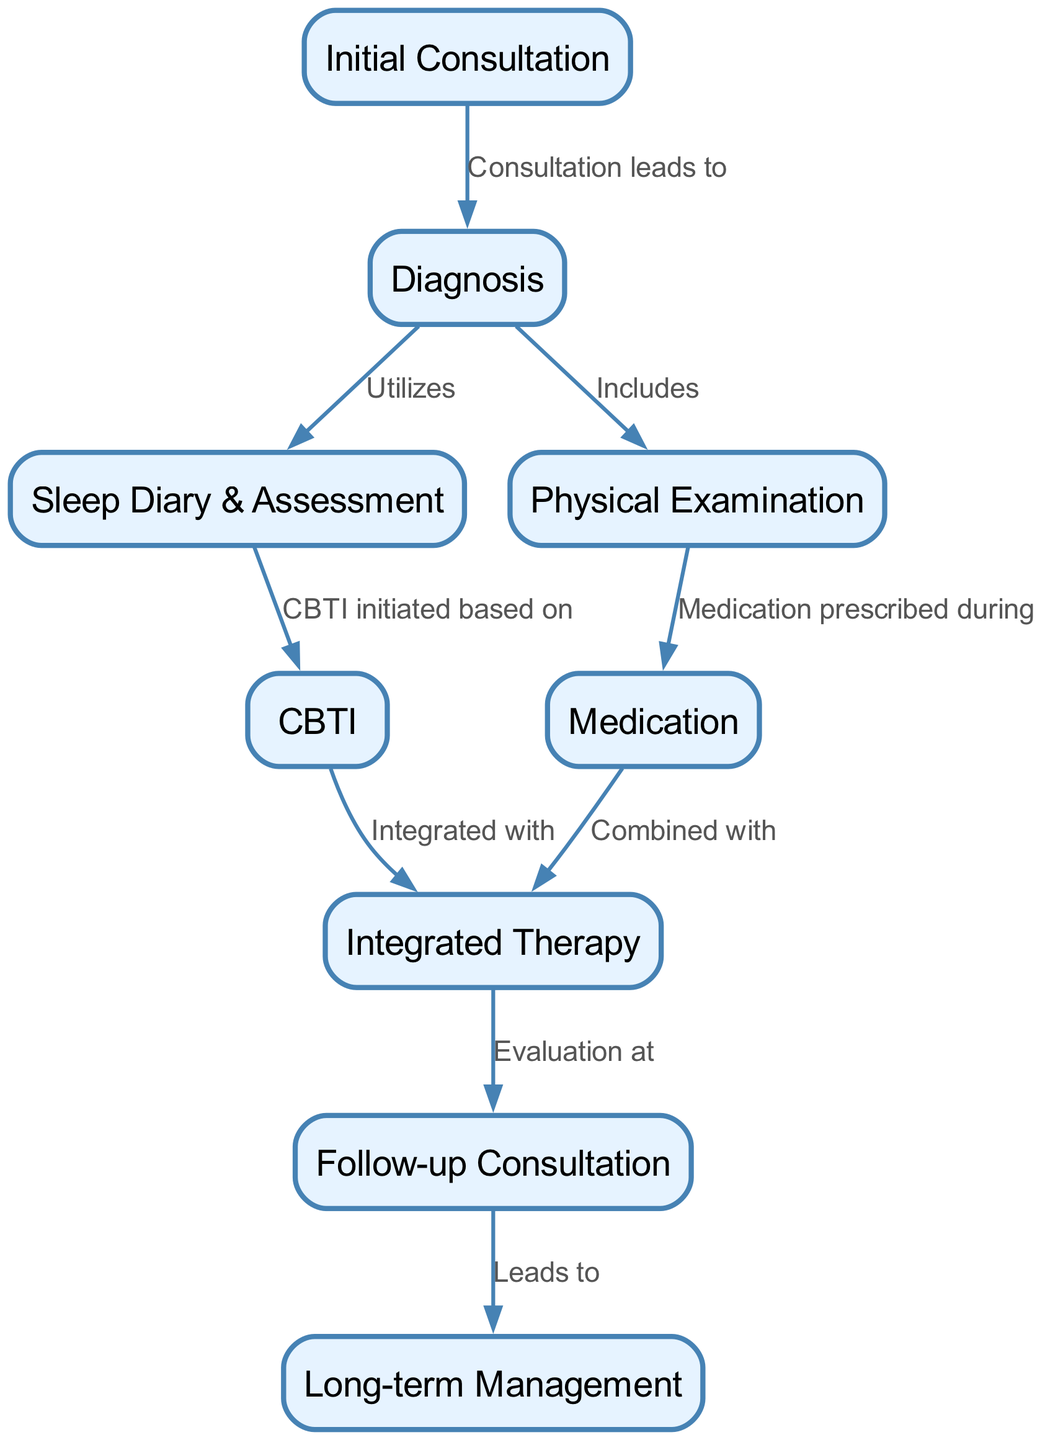What is the first step in the treatment journey? The first step in the treatment journey is indicated by the starting node labeled "Initial Consultation". This is the first action that initiates the patient journey towards addressing insomnia.
Answer: Initial Consultation How many total nodes are present in the diagram? To count the total nodes, we can look at the node data provided. There are 9 different nodes listed in the nodes section of the data, which represent the various steps in the treatment journey.
Answer: 9 What does "Diagnosis" lead to? The "Diagnosis" node is connected to two subsequent nodes: "Sleep Diary & Assessment" and "Physical Examination". This indicates that after a diagnosis, these assessments are utilized for further understanding the condition.
Answer: Sleep Diary & Assessment, Physical Examination What happens after the "Follow-up Consultation"? After the "Follow-up Consultation", the journey moves to "Long-term Management". This shows that follow-up evaluations lead into the strategies for ongoing management of the patient's insomnia.
Answer: Long-term Management What therapies are combined in "Integrated Therapy"? "Integrated Therapy" combines both "CBTI" and "Medication". According to the edges in the diagram, it indicates that treatment approaches for insomnia are integrated and utilized together for optimal outcomes.
Answer: CBTI and Medication How many edges are in the diagram? To determine the total number of edges, we can count the connections provided in the edges section of the data. There are 8 edges showing the relationships between the different nodes.
Answer: 8 Which node is reached from "Medication"? The node reached directly from "Medication" based on the diagram is "Integrated Therapy". This indicates that when a medication is prescribed, it is directed towards integrating it into therapy.
Answer: Integrated Therapy What does "CBTI" initiate based on? "CBTI" is initiated based on the assessments provided in the "Sleep Diary & Assessment". This shows that the initiation of cognitive behavioral therapy for insomnia is contingent upon the collected data from the patient's sleep evaluations.
Answer: Sleep Diary & Assessment How is "Integrated Therapy" evaluated? "Integrated Therapy" is evaluated during the "Follow-up Consultation". The diagram shows a direct edge connecting these two nodes, indicating that follow-ups are specifically aimed at evaluating the integrated approach of therapies.
Answer: Follow-up Consultation 